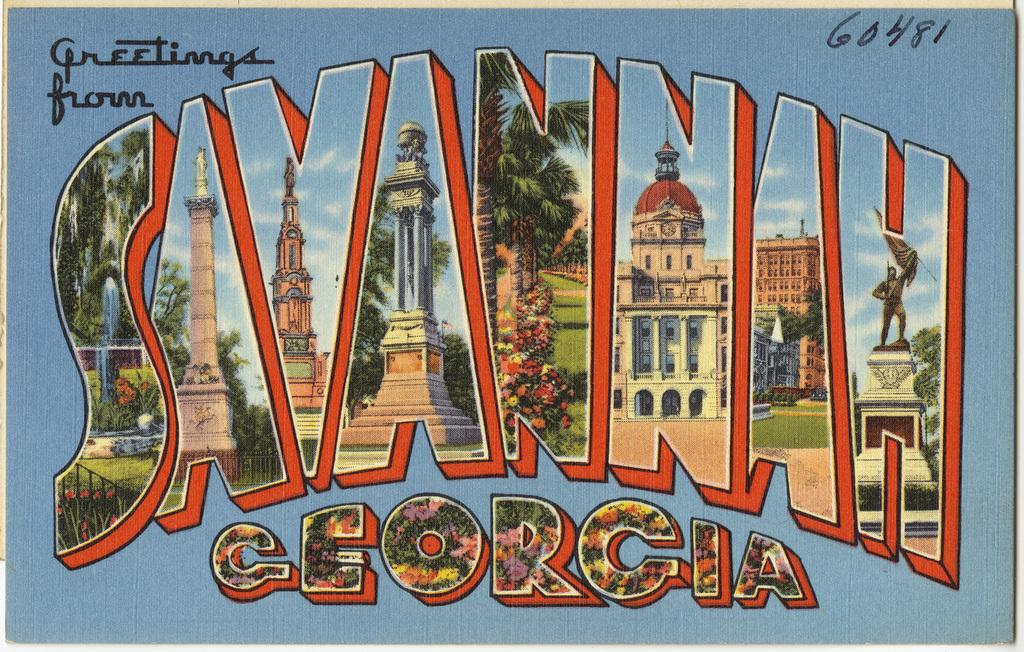<image>
Summarize the visual content of the image. A colorful post card sends greetings from Savannah Georgia. 